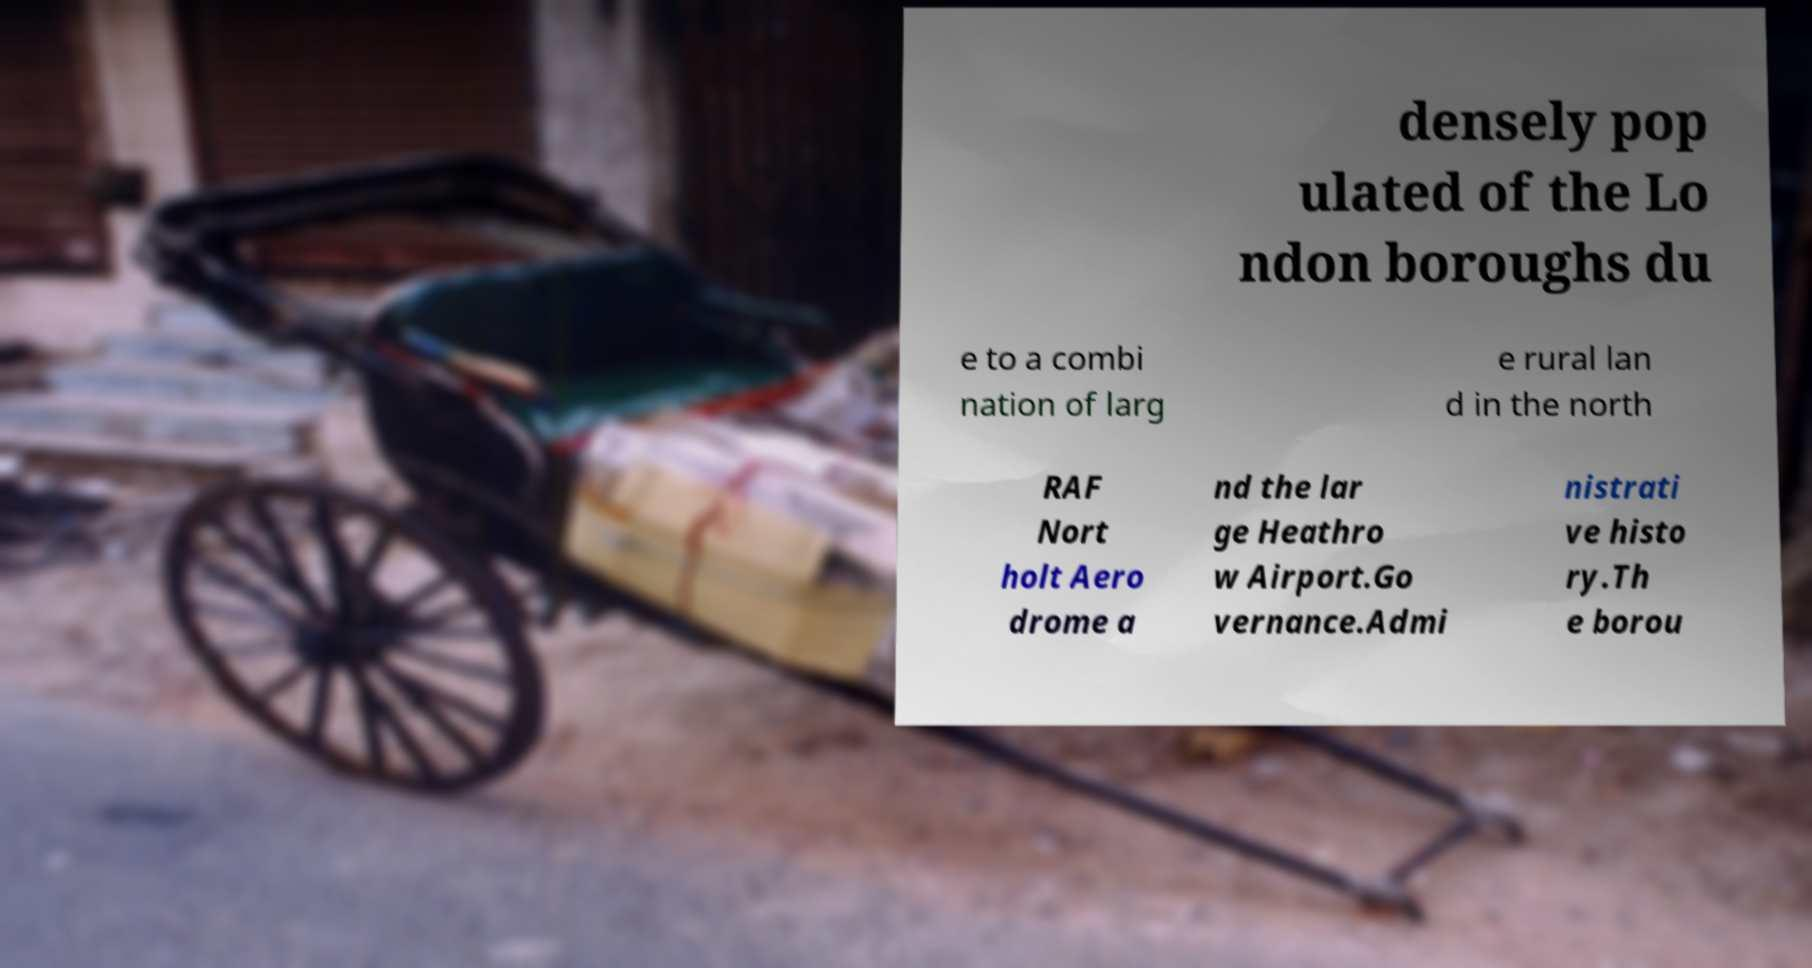What messages or text are displayed in this image? I need them in a readable, typed format. densely pop ulated of the Lo ndon boroughs du e to a combi nation of larg e rural lan d in the north RAF Nort holt Aero drome a nd the lar ge Heathro w Airport.Go vernance.Admi nistrati ve histo ry.Th e borou 